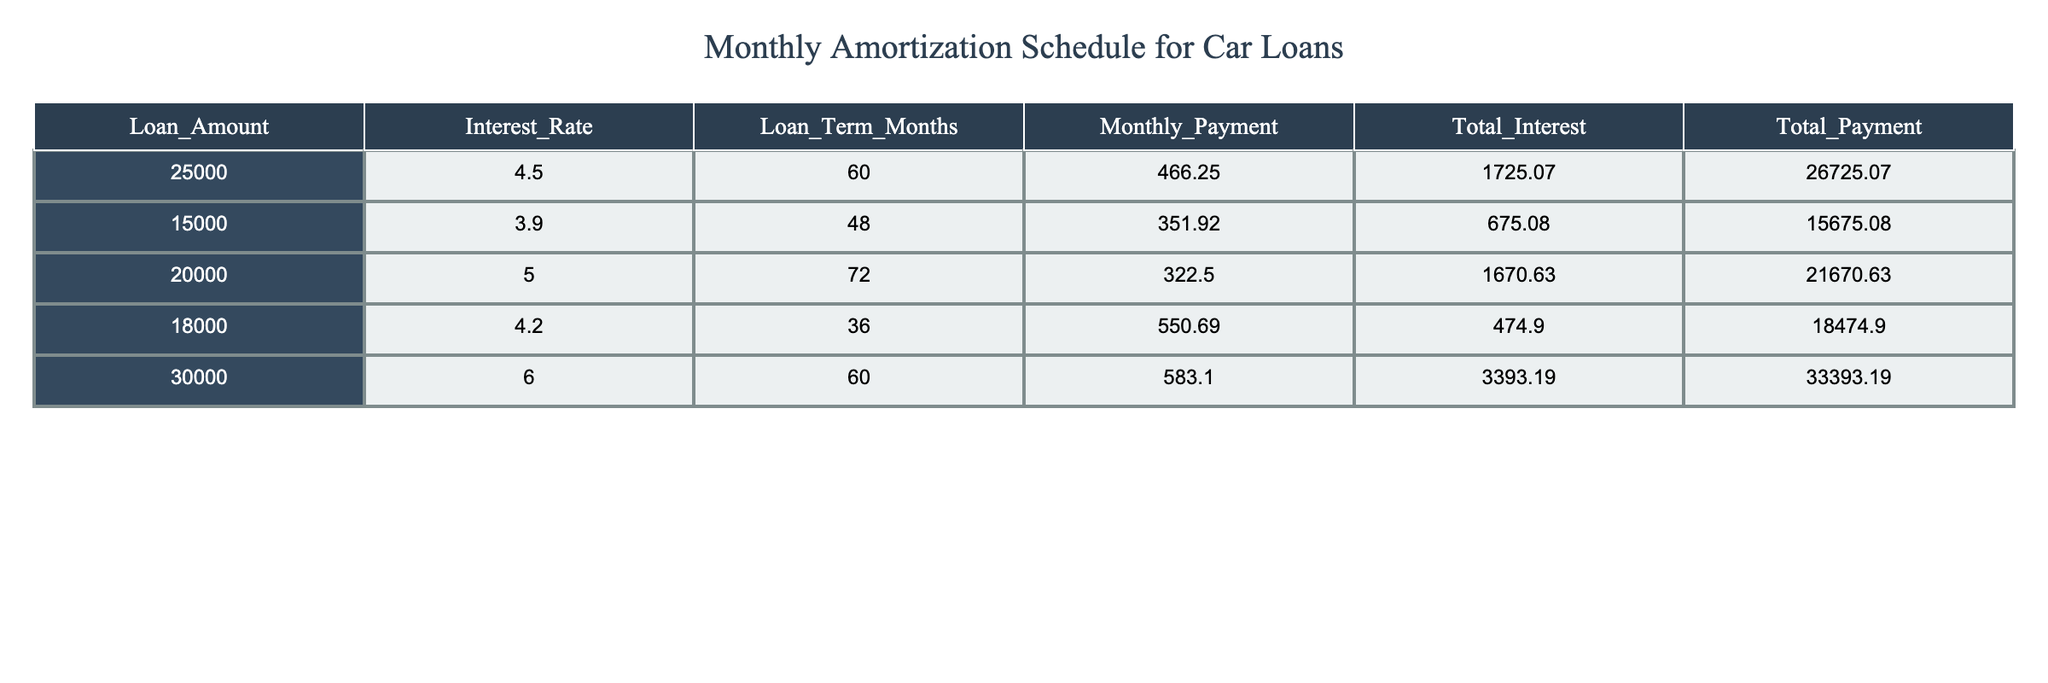What is the monthly payment for the loan amount of 20000? The table indicates that the monthly payment associated with the loan amount of 20000 is found in the corresponding row. You can look at the "Monthly_Payment" column for this loan amount, which is 322.50.
Answer: 322.50 What is the total payment for the car loan with an interest rate of 5.0%? To answer this, refer to the row with the interest rate of 5.0%. The "Total_Payment" column for this row shows the total payment, which is 21670.63.
Answer: 21670.63 How much interest will be paid in total for a loan amount of 30000? The total interest paid is recorded in the "Total_Interest" column for the loan amount of 30000. By checking the corresponding row, it is indicated that the total interest for this loan is 3393.19.
Answer: 3393.19 Is the total payment greater for the 25000 loan compared to the 15000 loan? By looking at the "Total_Payment" column, the total payment for the 25000 loan is 26725.07, while for the 15000 loan it is 15675.08. Since 26725.07 is greater than 15675.08, the statement is true.
Answer: Yes What is the difference in total interest between the 18000 loan and the 20000 loan? First, find the total interest for both loans from the "Total_Interest" column. The total interest for the 18000 loan is 474.90, and for the 20000 loan it is 1670.63. To find the difference, subtract these two values: 1670.63 - 474.90 equals 1195.73.
Answer: 1195.73 Which loan has the highest interest rate, and what is that rate? By examining the "Interest_Rate" column, the highest interest rate can be identified. The values are 4.5, 3.9, 5.0, 4.2, and 6.0. The maximum among these is 6.0, which corresponds to the loan amount of 30000.
Answer: 6.0 What is the average monthly payment for the loans listed? To calculate the average, you first sum up all the monthly payments: (466.25 + 351.92 + 322.50 + 550.69 + 583.10) equals 2274.46. Then, divide by the number of loans (5): 2274.46 / 5 provides an average monthly payment of 454.892.
Answer: 454.89 Which loan terms are longer than 60 months? Checking the "Loan_Term_Months" column reveals the loan terms are 60, 48, 72, 36, and 60. Only the loan of amount 20000 is longer than 60 months with a term of 72.
Answer: 20000 What is the total payment for all the loans combined? To find the overall total payment, sum all the values in the "Total_Payment" column: 26725.07 + 15675.08 + 21670.63 + 18474.90 + 33393.19. Adding these together results in 115038.87.
Answer: 115038.87 